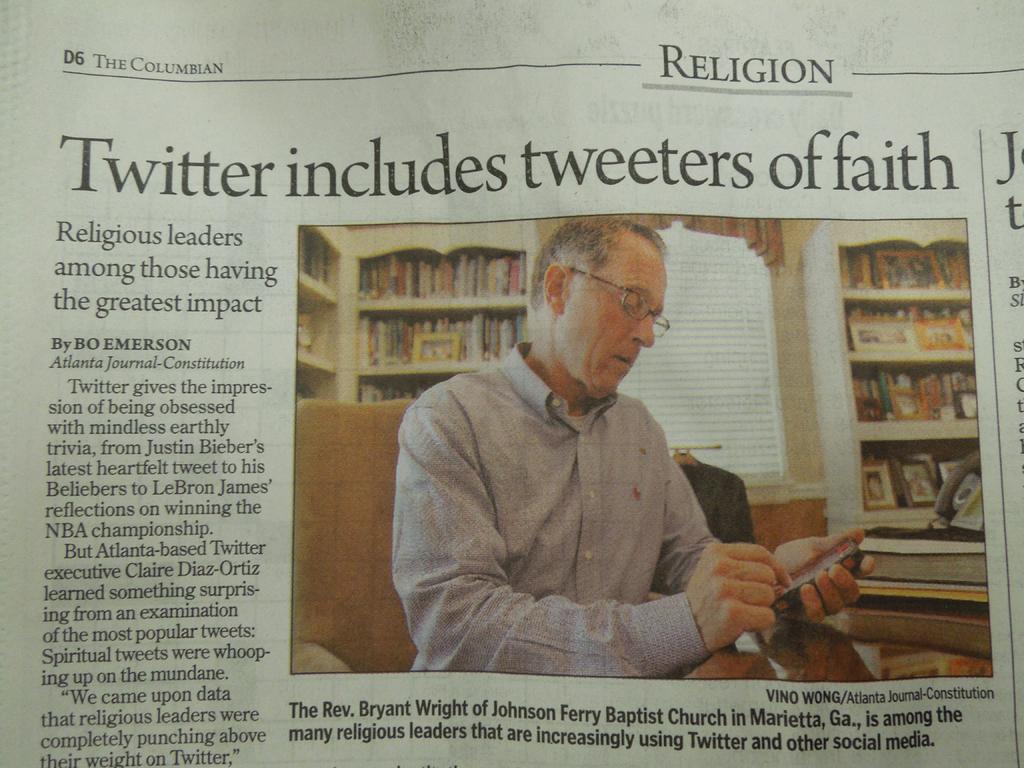In one or two sentences, can you explain what this image depicts? In this picture I can see a paper on which there is something and I see a picture, in which I can see a man who is holding a thing and in the background I can see the racks on which there are number of things. 